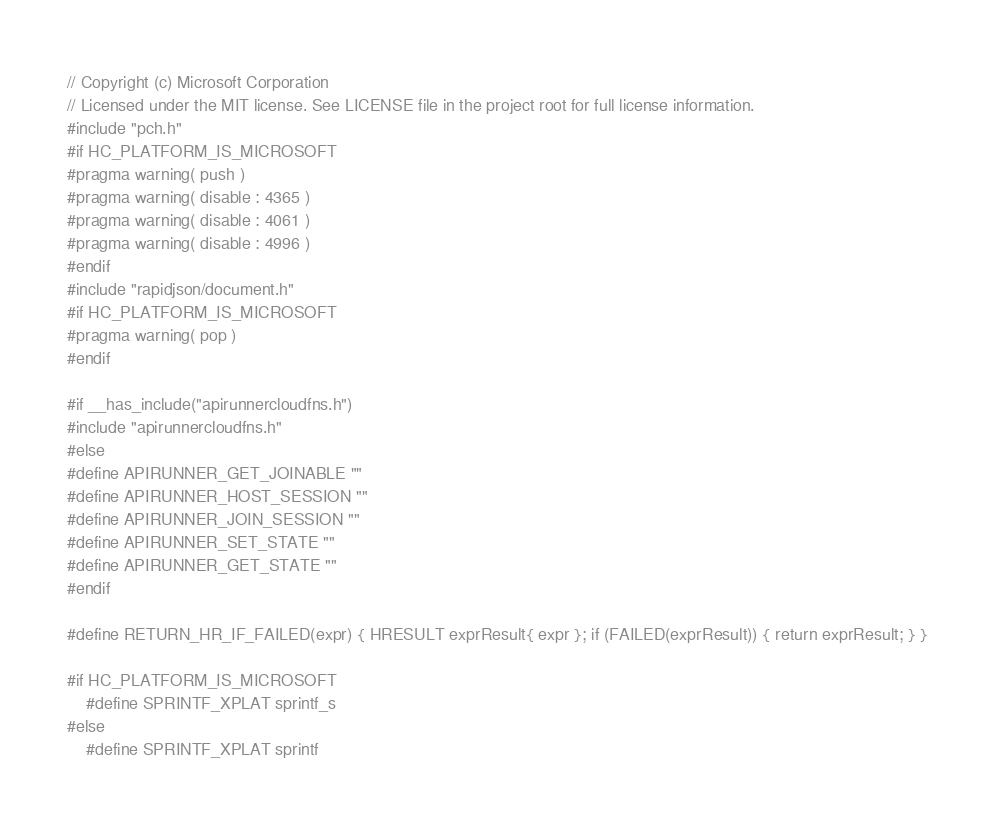Convert code to text. <code><loc_0><loc_0><loc_500><loc_500><_C++_>// Copyright (c) Microsoft Corporation
// Licensed under the MIT license. See LICENSE file in the project root for full license information.
#include "pch.h"
#if HC_PLATFORM_IS_MICROSOFT
#pragma warning( push )
#pragma warning( disable : 4365 )
#pragma warning( disable : 4061 )
#pragma warning( disable : 4996 )
#endif
#include "rapidjson/document.h"
#if HC_PLATFORM_IS_MICROSOFT
#pragma warning( pop )
#endif

#if __has_include("apirunnercloudfns.h")
#include "apirunnercloudfns.h"
#else
#define APIRUNNER_GET_JOINABLE ""
#define APIRUNNER_HOST_SESSION ""
#define APIRUNNER_JOIN_SESSION ""
#define APIRUNNER_SET_STATE ""
#define APIRUNNER_GET_STATE ""
#endif

#define RETURN_HR_IF_FAILED(expr) { HRESULT exprResult{ expr }; if (FAILED(exprResult)) { return exprResult; } }

#if HC_PLATFORM_IS_MICROSOFT
    #define SPRINTF_XPLAT sprintf_s
#else
    #define SPRINTF_XPLAT sprintf</code> 